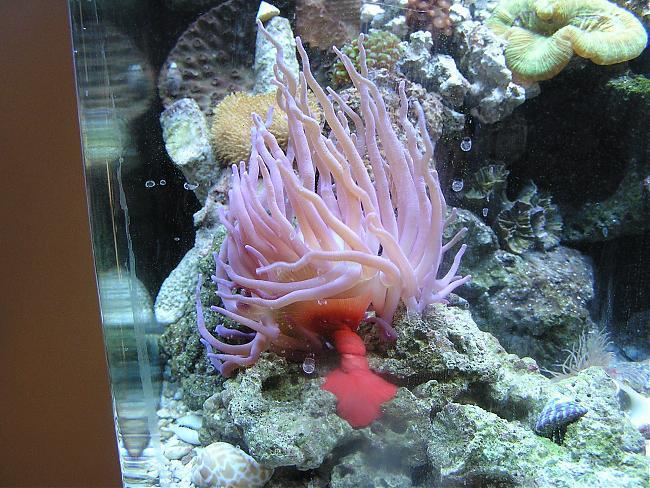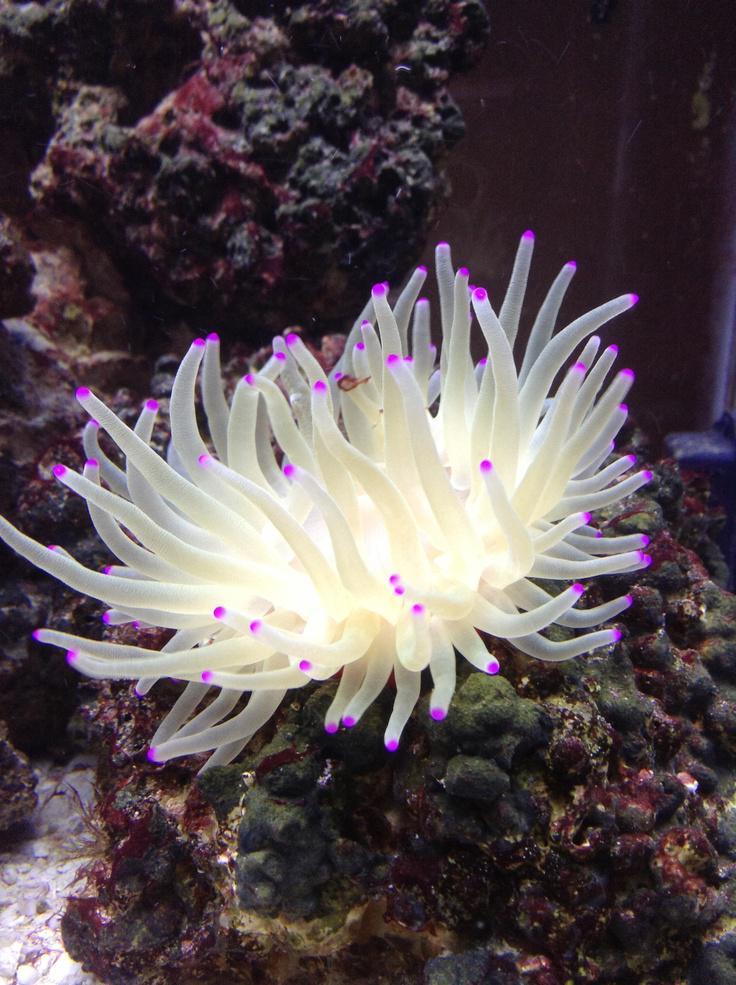The first image is the image on the left, the second image is the image on the right. Analyze the images presented: Is the assertion "An image shows one white anemone with vivid purple dots at the end of its tendrils." valid? Answer yes or no. Yes. The first image is the image on the left, the second image is the image on the right. Given the left and right images, does the statement "There are purple dots covering the end of the coral reef’s individual arms." hold true? Answer yes or no. Yes. 